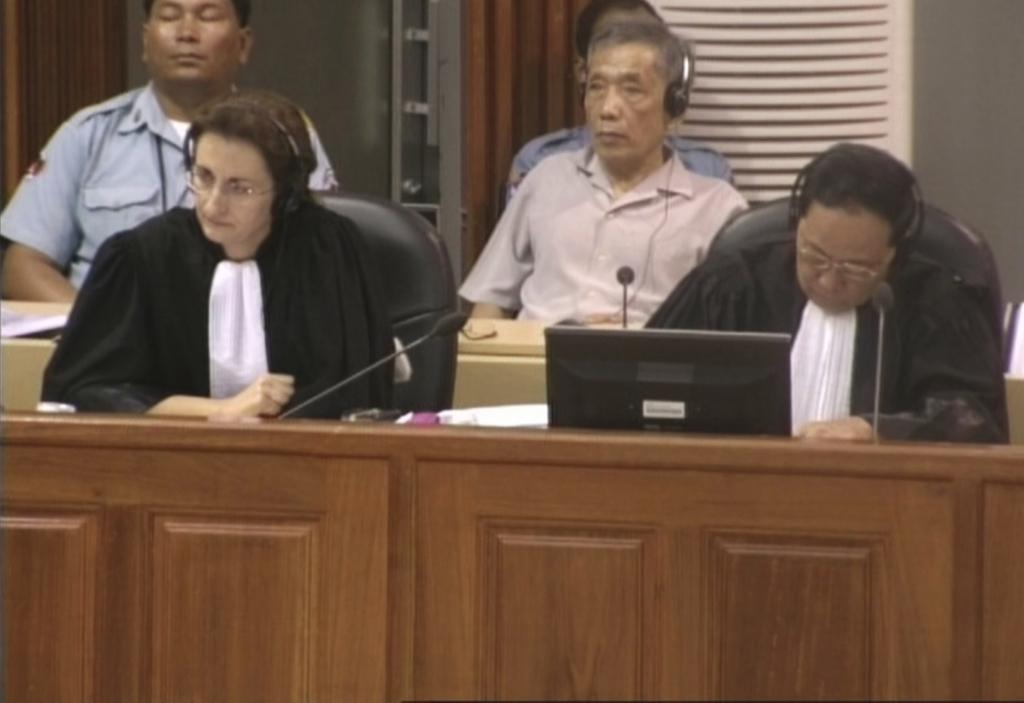How would you summarize this image in a sentence or two? In this picture I can see there are four people visible in the image and they are wearing headset and there is a monitor in front of them there are microphones and in the backdrop there is a wall. 